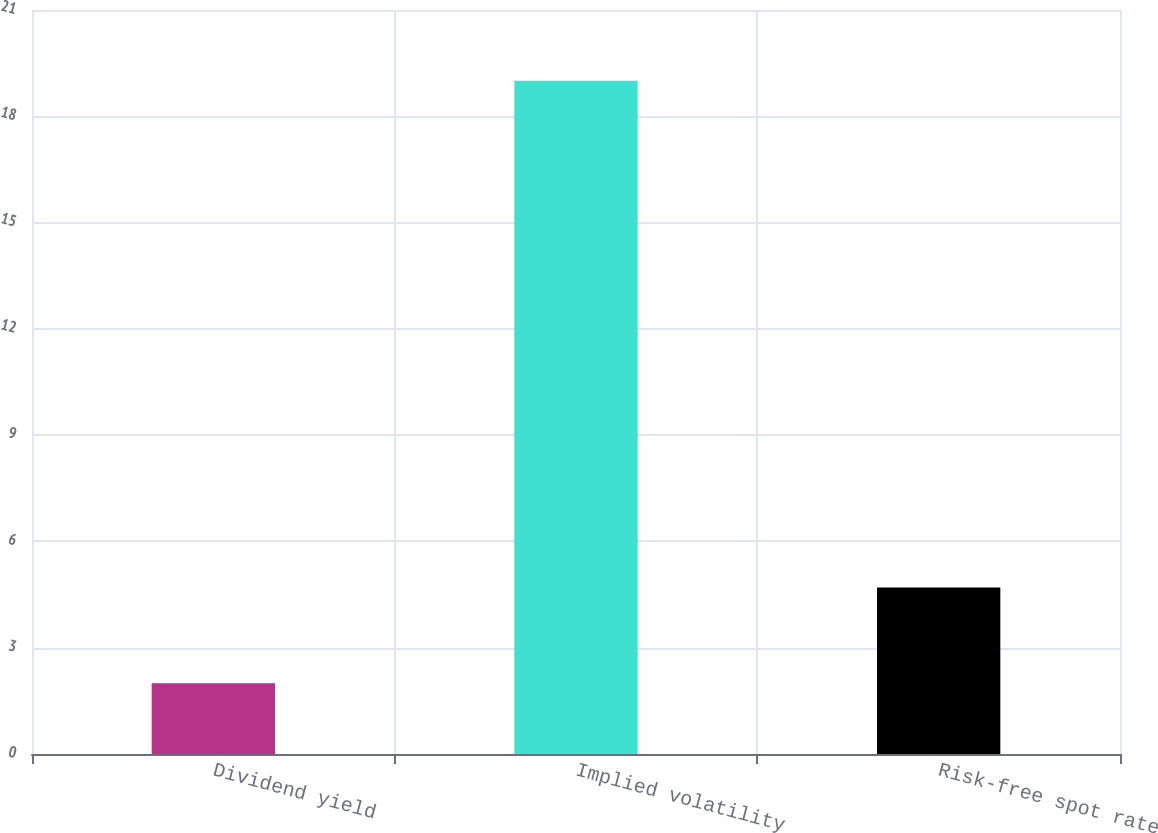<chart> <loc_0><loc_0><loc_500><loc_500><bar_chart><fcel>Dividend yield<fcel>Implied volatility<fcel>Risk-free spot rate<nl><fcel>2<fcel>19<fcel>4.7<nl></chart> 